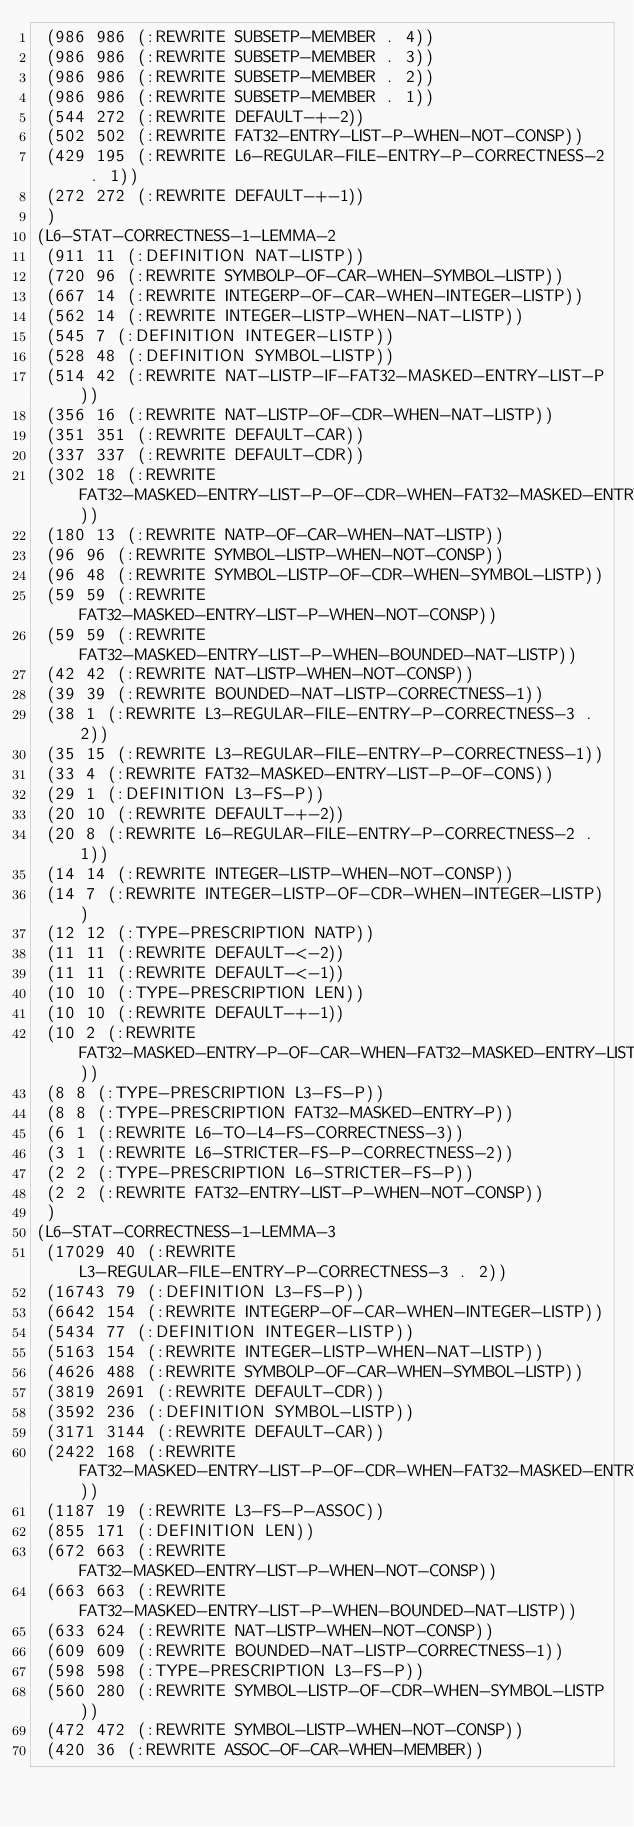Convert code to text. <code><loc_0><loc_0><loc_500><loc_500><_Lisp_> (986 986 (:REWRITE SUBSETP-MEMBER . 4))
 (986 986 (:REWRITE SUBSETP-MEMBER . 3))
 (986 986 (:REWRITE SUBSETP-MEMBER . 2))
 (986 986 (:REWRITE SUBSETP-MEMBER . 1))
 (544 272 (:REWRITE DEFAULT-+-2))
 (502 502 (:REWRITE FAT32-ENTRY-LIST-P-WHEN-NOT-CONSP))
 (429 195 (:REWRITE L6-REGULAR-FILE-ENTRY-P-CORRECTNESS-2 . 1))
 (272 272 (:REWRITE DEFAULT-+-1))
 )
(L6-STAT-CORRECTNESS-1-LEMMA-2
 (911 11 (:DEFINITION NAT-LISTP))
 (720 96 (:REWRITE SYMBOLP-OF-CAR-WHEN-SYMBOL-LISTP))
 (667 14 (:REWRITE INTEGERP-OF-CAR-WHEN-INTEGER-LISTP))
 (562 14 (:REWRITE INTEGER-LISTP-WHEN-NAT-LISTP))
 (545 7 (:DEFINITION INTEGER-LISTP))
 (528 48 (:DEFINITION SYMBOL-LISTP))
 (514 42 (:REWRITE NAT-LISTP-IF-FAT32-MASKED-ENTRY-LIST-P))
 (356 16 (:REWRITE NAT-LISTP-OF-CDR-WHEN-NAT-LISTP))
 (351 351 (:REWRITE DEFAULT-CAR))
 (337 337 (:REWRITE DEFAULT-CDR))
 (302 18 (:REWRITE FAT32-MASKED-ENTRY-LIST-P-OF-CDR-WHEN-FAT32-MASKED-ENTRY-LIST-P))
 (180 13 (:REWRITE NATP-OF-CAR-WHEN-NAT-LISTP))
 (96 96 (:REWRITE SYMBOL-LISTP-WHEN-NOT-CONSP))
 (96 48 (:REWRITE SYMBOL-LISTP-OF-CDR-WHEN-SYMBOL-LISTP))
 (59 59 (:REWRITE FAT32-MASKED-ENTRY-LIST-P-WHEN-NOT-CONSP))
 (59 59 (:REWRITE FAT32-MASKED-ENTRY-LIST-P-WHEN-BOUNDED-NAT-LISTP))
 (42 42 (:REWRITE NAT-LISTP-WHEN-NOT-CONSP))
 (39 39 (:REWRITE BOUNDED-NAT-LISTP-CORRECTNESS-1))
 (38 1 (:REWRITE L3-REGULAR-FILE-ENTRY-P-CORRECTNESS-3 . 2))
 (35 15 (:REWRITE L3-REGULAR-FILE-ENTRY-P-CORRECTNESS-1))
 (33 4 (:REWRITE FAT32-MASKED-ENTRY-LIST-P-OF-CONS))
 (29 1 (:DEFINITION L3-FS-P))
 (20 10 (:REWRITE DEFAULT-+-2))
 (20 8 (:REWRITE L6-REGULAR-FILE-ENTRY-P-CORRECTNESS-2 . 1))
 (14 14 (:REWRITE INTEGER-LISTP-WHEN-NOT-CONSP))
 (14 7 (:REWRITE INTEGER-LISTP-OF-CDR-WHEN-INTEGER-LISTP))
 (12 12 (:TYPE-PRESCRIPTION NATP))
 (11 11 (:REWRITE DEFAULT-<-2))
 (11 11 (:REWRITE DEFAULT-<-1))
 (10 10 (:TYPE-PRESCRIPTION LEN))
 (10 10 (:REWRITE DEFAULT-+-1))
 (10 2 (:REWRITE FAT32-MASKED-ENTRY-P-OF-CAR-WHEN-FAT32-MASKED-ENTRY-LIST-P))
 (8 8 (:TYPE-PRESCRIPTION L3-FS-P))
 (8 8 (:TYPE-PRESCRIPTION FAT32-MASKED-ENTRY-P))
 (6 1 (:REWRITE L6-TO-L4-FS-CORRECTNESS-3))
 (3 1 (:REWRITE L6-STRICTER-FS-P-CORRECTNESS-2))
 (2 2 (:TYPE-PRESCRIPTION L6-STRICTER-FS-P))
 (2 2 (:REWRITE FAT32-ENTRY-LIST-P-WHEN-NOT-CONSP))
 )
(L6-STAT-CORRECTNESS-1-LEMMA-3
 (17029 40 (:REWRITE L3-REGULAR-FILE-ENTRY-P-CORRECTNESS-3 . 2))
 (16743 79 (:DEFINITION L3-FS-P))
 (6642 154 (:REWRITE INTEGERP-OF-CAR-WHEN-INTEGER-LISTP))
 (5434 77 (:DEFINITION INTEGER-LISTP))
 (5163 154 (:REWRITE INTEGER-LISTP-WHEN-NAT-LISTP))
 (4626 488 (:REWRITE SYMBOLP-OF-CAR-WHEN-SYMBOL-LISTP))
 (3819 2691 (:REWRITE DEFAULT-CDR))
 (3592 236 (:DEFINITION SYMBOL-LISTP))
 (3171 3144 (:REWRITE DEFAULT-CAR))
 (2422 168 (:REWRITE FAT32-MASKED-ENTRY-LIST-P-OF-CDR-WHEN-FAT32-MASKED-ENTRY-LIST-P))
 (1187 19 (:REWRITE L3-FS-P-ASSOC))
 (855 171 (:DEFINITION LEN))
 (672 663 (:REWRITE FAT32-MASKED-ENTRY-LIST-P-WHEN-NOT-CONSP))
 (663 663 (:REWRITE FAT32-MASKED-ENTRY-LIST-P-WHEN-BOUNDED-NAT-LISTP))
 (633 624 (:REWRITE NAT-LISTP-WHEN-NOT-CONSP))
 (609 609 (:REWRITE BOUNDED-NAT-LISTP-CORRECTNESS-1))
 (598 598 (:TYPE-PRESCRIPTION L3-FS-P))
 (560 280 (:REWRITE SYMBOL-LISTP-OF-CDR-WHEN-SYMBOL-LISTP))
 (472 472 (:REWRITE SYMBOL-LISTP-WHEN-NOT-CONSP))
 (420 36 (:REWRITE ASSOC-OF-CAR-WHEN-MEMBER))</code> 